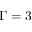<formula> <loc_0><loc_0><loc_500><loc_500>\Gamma = 3</formula> 